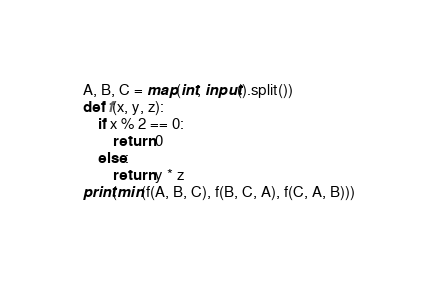Convert code to text. <code><loc_0><loc_0><loc_500><loc_500><_Python_>A, B, C = map(int, input().split())
def f(x, y, z):
    if x % 2 == 0:
        return 0
    else:
        return y * z
print(min(f(A, B, C), f(B, C, A), f(C, A, B)))
</code> 